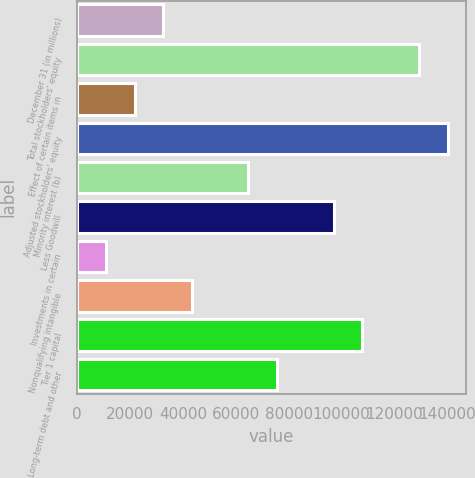Convert chart to OTSL. <chart><loc_0><loc_0><loc_500><loc_500><bar_chart><fcel>December 31 (in millions)<fcel>Total stockholders' equity<fcel>Effect of certain items in<fcel>Adjusted stockholders' equity<fcel>Minority interest (b)<fcel>Less Goodwill<fcel>Investments in certain<fcel>Nonqualifying intangible<fcel>Tier 1 capital<fcel>Long-term debt and other<nl><fcel>32530.7<fcel>129343<fcel>21773.8<fcel>140100<fcel>64801.4<fcel>97072.1<fcel>11016.9<fcel>43287.6<fcel>107829<fcel>75558.3<nl></chart> 